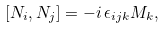<formula> <loc_0><loc_0><loc_500><loc_500>[ N _ { i } , N _ { j } ] = - i \, \epsilon _ { i j k } M _ { k } ,</formula> 